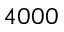<formula> <loc_0><loc_0><loc_500><loc_500>4 0 0 0</formula> 